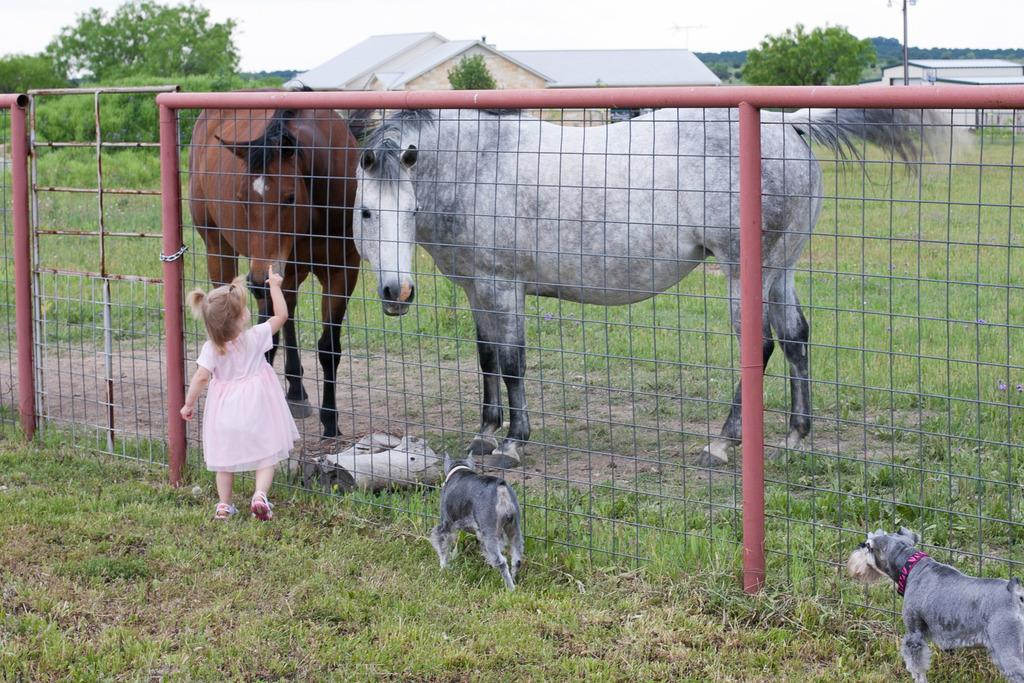How many horses are present in the image? There are 2 horses in the image. How many dogs are present in the image? There are 2 dogs in the image. What is the girl doing in the image? The girl is on the grass. What is the girl's location in relation to the fence? The fence is in the image, but the girl's specific location relative to the fence is not mentioned. What can be seen in the background of the image? There are trees and houses in the background of the image. What type of advice is the girl giving to the orange in the image? There is no orange present in the image, and therefore no such interaction can be observed. 